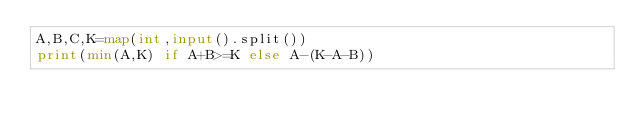<code> <loc_0><loc_0><loc_500><loc_500><_Python_>A,B,C,K=map(int,input().split())
print(min(A,K) if A+B>=K else A-(K-A-B))</code> 